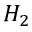<formula> <loc_0><loc_0><loc_500><loc_500>H _ { 2 }</formula> 